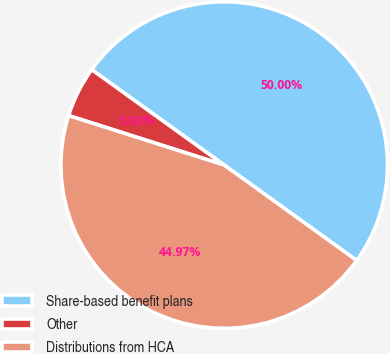<chart> <loc_0><loc_0><loc_500><loc_500><pie_chart><fcel>Share-based benefit plans<fcel>Other<fcel>Distributions from HCA<nl><fcel>50.0%<fcel>5.03%<fcel>44.97%<nl></chart> 